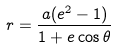Convert formula to latex. <formula><loc_0><loc_0><loc_500><loc_500>r = \frac { a ( e ^ { 2 } - 1 ) } { 1 + e \cos \theta }</formula> 